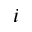Convert formula to latex. <formula><loc_0><loc_0><loc_500><loc_500>_ { i }</formula> 